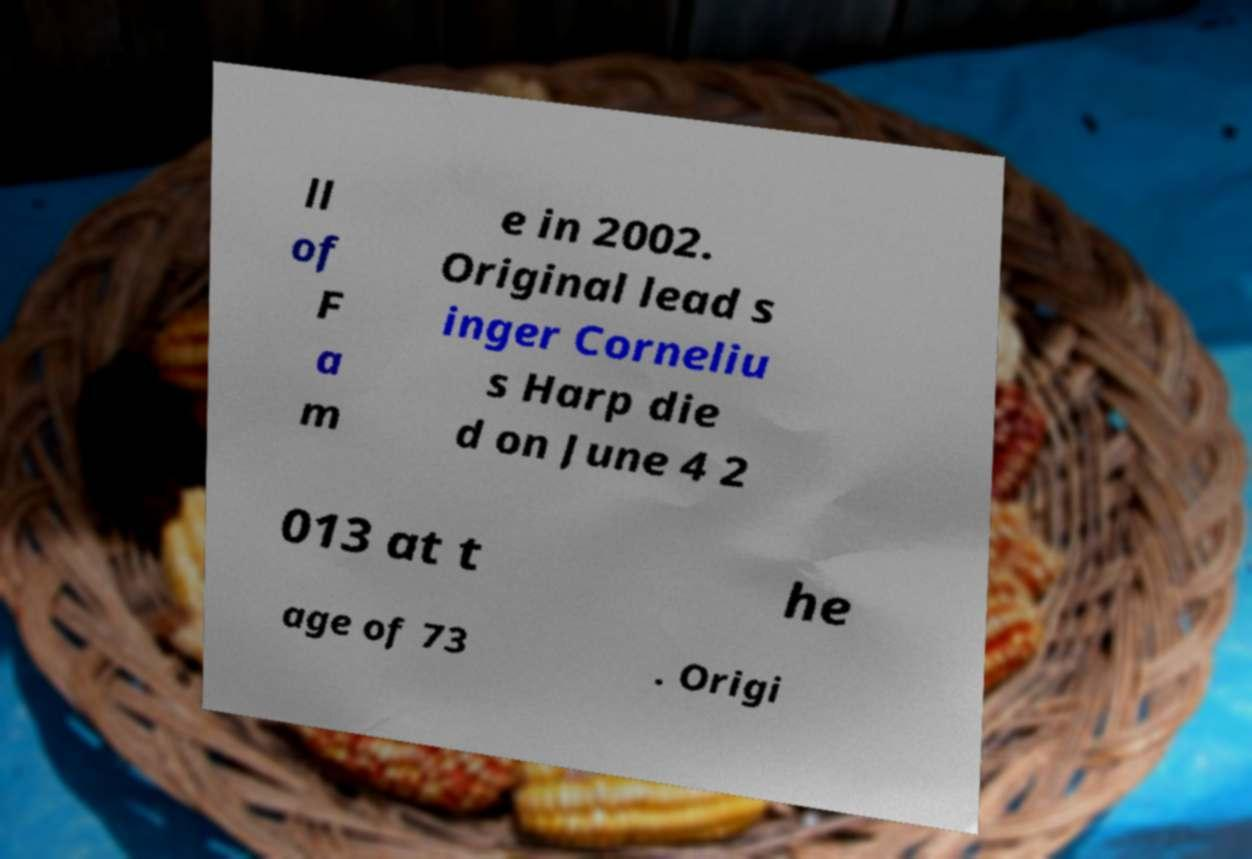Can you read and provide the text displayed in the image?This photo seems to have some interesting text. Can you extract and type it out for me? ll of F a m e in 2002. Original lead s inger Corneliu s Harp die d on June 4 2 013 at t he age of 73 . Origi 